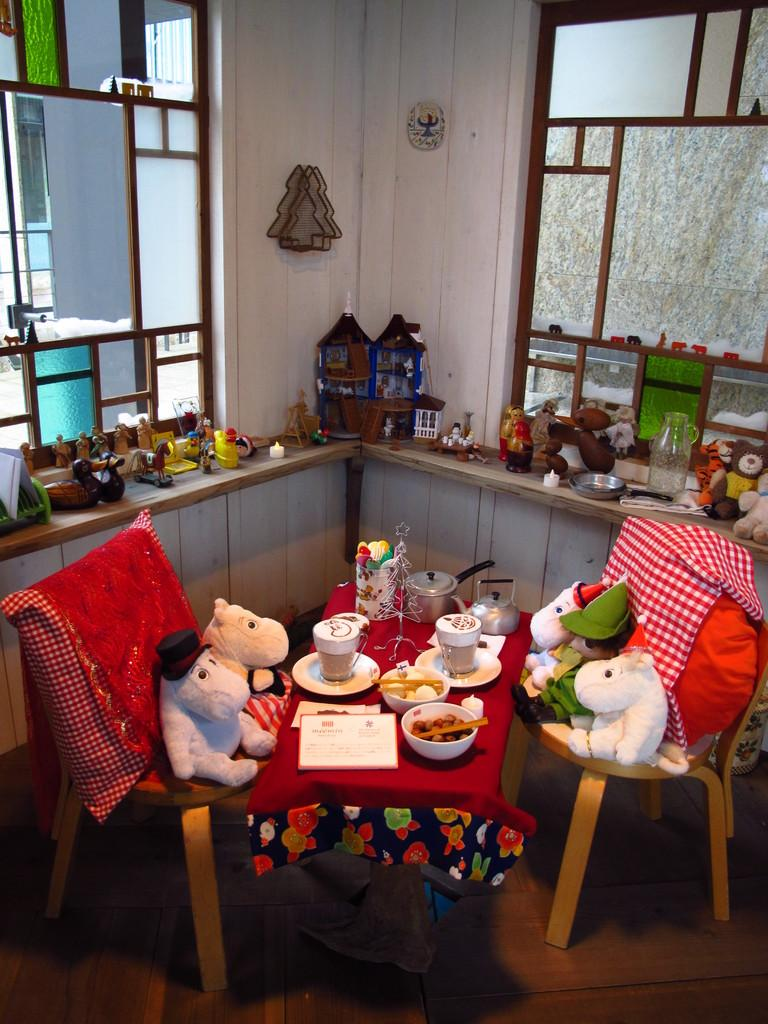What is placed on the chairs in the image? There are soft toys and cushions on the chairs. What can be found in the bowls and cups in the image? There is food in bowls and cups in the image. What is on the table in the image? There are plates on the table. What else is present in the image besides the items mentioned? There are toys on the side. Can you tell me how many kittens are playing with a spade in the image? There are no kittens or spades present in the image. What type of fact can be seen in the image? There is no fact visible in the image; it contains soft toys, cushions, food, plates, and toys. 